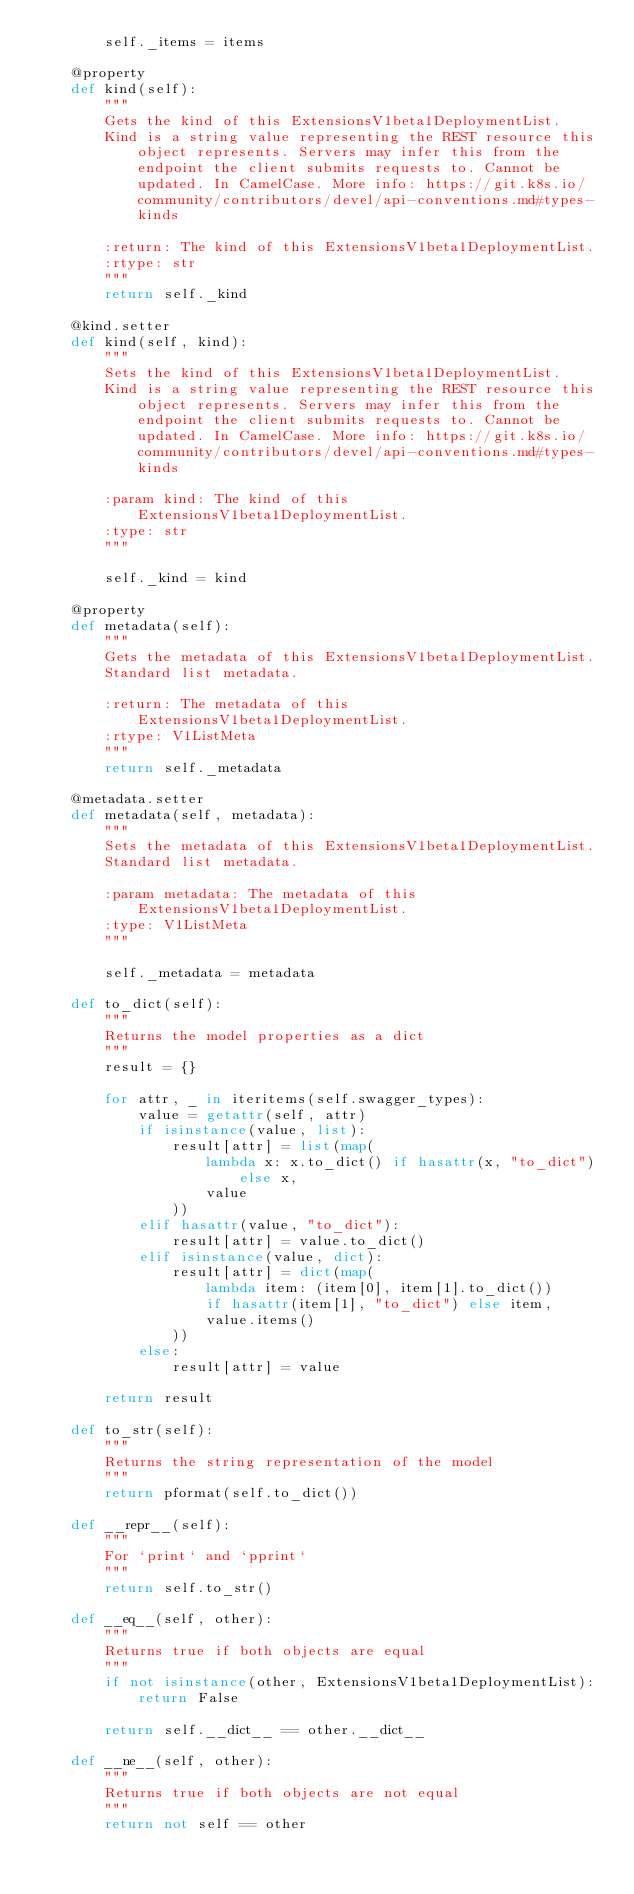<code> <loc_0><loc_0><loc_500><loc_500><_Python_>        self._items = items

    @property
    def kind(self):
        """
        Gets the kind of this ExtensionsV1beta1DeploymentList.
        Kind is a string value representing the REST resource this object represents. Servers may infer this from the endpoint the client submits requests to. Cannot be updated. In CamelCase. More info: https://git.k8s.io/community/contributors/devel/api-conventions.md#types-kinds

        :return: The kind of this ExtensionsV1beta1DeploymentList.
        :rtype: str
        """
        return self._kind

    @kind.setter
    def kind(self, kind):
        """
        Sets the kind of this ExtensionsV1beta1DeploymentList.
        Kind is a string value representing the REST resource this object represents. Servers may infer this from the endpoint the client submits requests to. Cannot be updated. In CamelCase. More info: https://git.k8s.io/community/contributors/devel/api-conventions.md#types-kinds

        :param kind: The kind of this ExtensionsV1beta1DeploymentList.
        :type: str
        """

        self._kind = kind

    @property
    def metadata(self):
        """
        Gets the metadata of this ExtensionsV1beta1DeploymentList.
        Standard list metadata.

        :return: The metadata of this ExtensionsV1beta1DeploymentList.
        :rtype: V1ListMeta
        """
        return self._metadata

    @metadata.setter
    def metadata(self, metadata):
        """
        Sets the metadata of this ExtensionsV1beta1DeploymentList.
        Standard list metadata.

        :param metadata: The metadata of this ExtensionsV1beta1DeploymentList.
        :type: V1ListMeta
        """

        self._metadata = metadata

    def to_dict(self):
        """
        Returns the model properties as a dict
        """
        result = {}

        for attr, _ in iteritems(self.swagger_types):
            value = getattr(self, attr)
            if isinstance(value, list):
                result[attr] = list(map(
                    lambda x: x.to_dict() if hasattr(x, "to_dict") else x,
                    value
                ))
            elif hasattr(value, "to_dict"):
                result[attr] = value.to_dict()
            elif isinstance(value, dict):
                result[attr] = dict(map(
                    lambda item: (item[0], item[1].to_dict())
                    if hasattr(item[1], "to_dict") else item,
                    value.items()
                ))
            else:
                result[attr] = value

        return result

    def to_str(self):
        """
        Returns the string representation of the model
        """
        return pformat(self.to_dict())

    def __repr__(self):
        """
        For `print` and `pprint`
        """
        return self.to_str()

    def __eq__(self, other):
        """
        Returns true if both objects are equal
        """
        if not isinstance(other, ExtensionsV1beta1DeploymentList):
            return False

        return self.__dict__ == other.__dict__

    def __ne__(self, other):
        """
        Returns true if both objects are not equal
        """
        return not self == other
</code> 